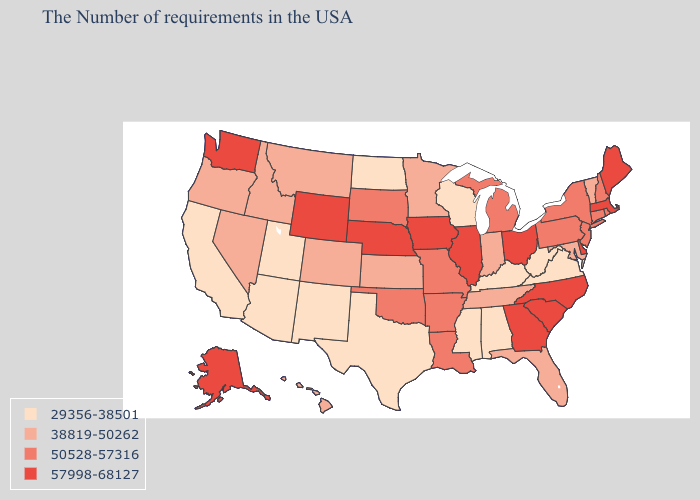What is the lowest value in states that border Michigan?
Quick response, please. 29356-38501. What is the highest value in the Northeast ?
Write a very short answer. 57998-68127. Does Ohio have the highest value in the USA?
Quick response, please. Yes. How many symbols are there in the legend?
Short answer required. 4. What is the highest value in the MidWest ?
Write a very short answer. 57998-68127. What is the value of Tennessee?
Write a very short answer. 38819-50262. Name the states that have a value in the range 57998-68127?
Short answer required. Maine, Massachusetts, Delaware, North Carolina, South Carolina, Ohio, Georgia, Illinois, Iowa, Nebraska, Wyoming, Washington, Alaska. Name the states that have a value in the range 29356-38501?
Write a very short answer. Virginia, West Virginia, Kentucky, Alabama, Wisconsin, Mississippi, Texas, North Dakota, New Mexico, Utah, Arizona, California. Name the states that have a value in the range 38819-50262?
Write a very short answer. Vermont, Maryland, Florida, Indiana, Tennessee, Minnesota, Kansas, Colorado, Montana, Idaho, Nevada, Oregon, Hawaii. What is the highest value in the USA?
Quick response, please. 57998-68127. What is the value of Connecticut?
Keep it brief. 50528-57316. Does Missouri have the highest value in the USA?
Be succinct. No. Name the states that have a value in the range 38819-50262?
Write a very short answer. Vermont, Maryland, Florida, Indiana, Tennessee, Minnesota, Kansas, Colorado, Montana, Idaho, Nevada, Oregon, Hawaii. Does Indiana have the same value as North Carolina?
Concise answer only. No. Name the states that have a value in the range 50528-57316?
Concise answer only. Rhode Island, New Hampshire, Connecticut, New York, New Jersey, Pennsylvania, Michigan, Louisiana, Missouri, Arkansas, Oklahoma, South Dakota. 